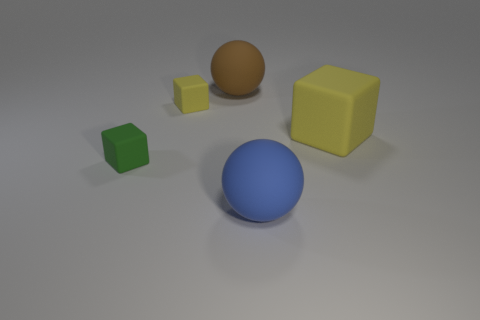There is a green matte object; is it the same size as the rubber block that is on the right side of the blue rubber sphere?
Offer a terse response. No. What number of big yellow rubber objects are on the left side of the small rubber thing that is left of the yellow object behind the big yellow rubber object?
Make the answer very short. 0. There is a small green object; are there any rubber cubes behind it?
Provide a short and direct response. Yes. What shape is the big brown thing?
Offer a terse response. Sphere. There is a yellow object to the left of the large object behind the block on the right side of the blue matte object; what is its shape?
Provide a short and direct response. Cube. What number of other objects are the same shape as the small yellow matte object?
Make the answer very short. 2. Is the material of the green object the same as the ball that is in front of the brown sphere?
Offer a very short reply. Yes. There is a object that is both left of the large brown rubber sphere and in front of the large yellow rubber cube; what is its material?
Your answer should be compact. Rubber. What color is the large cube that is in front of the large rubber ball that is behind the tiny yellow rubber thing?
Your answer should be compact. Yellow. Are there fewer green rubber things than red cylinders?
Your answer should be compact. No. 